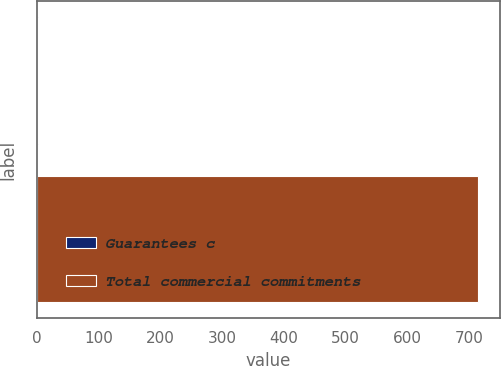Convert chart to OTSL. <chart><loc_0><loc_0><loc_500><loc_500><bar_chart><fcel>Guarantees c<fcel>Total commercial commitments<nl><fcel>2<fcel>715<nl></chart> 